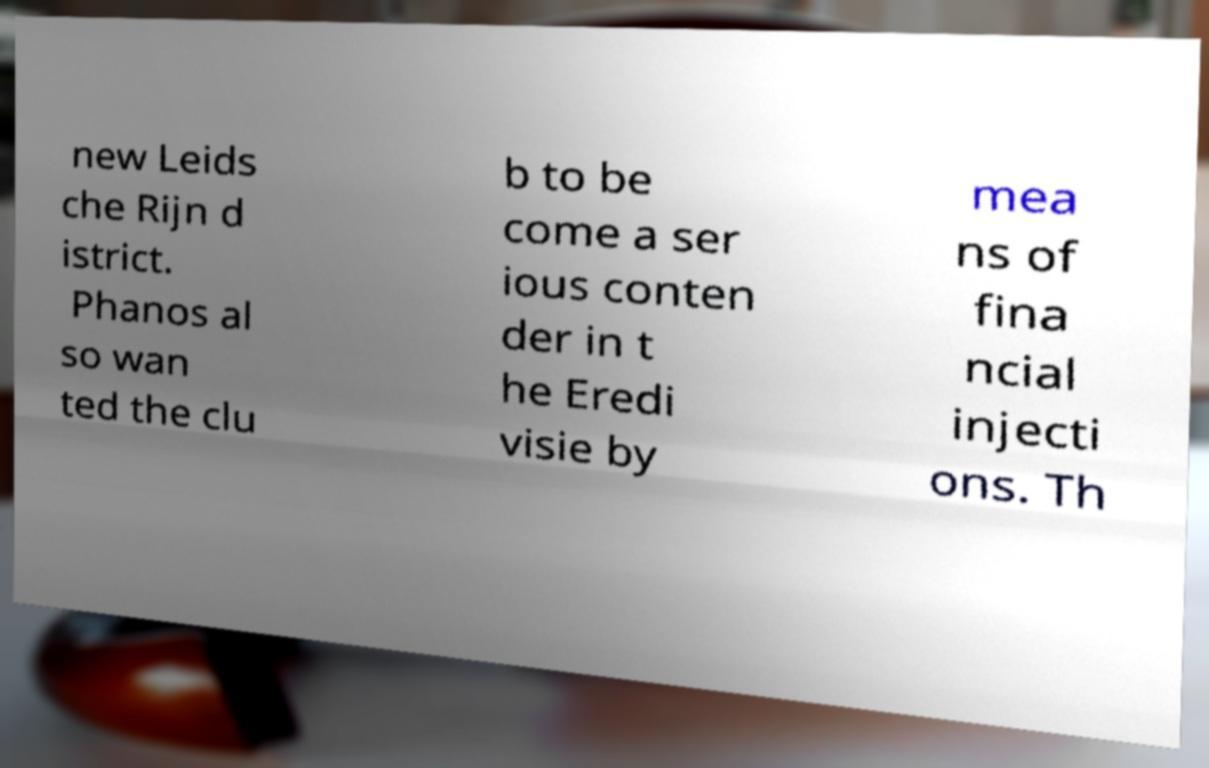Please read and relay the text visible in this image. What does it say? new Leids che Rijn d istrict. Phanos al so wan ted the clu b to be come a ser ious conten der in t he Eredi visie by mea ns of fina ncial injecti ons. Th 